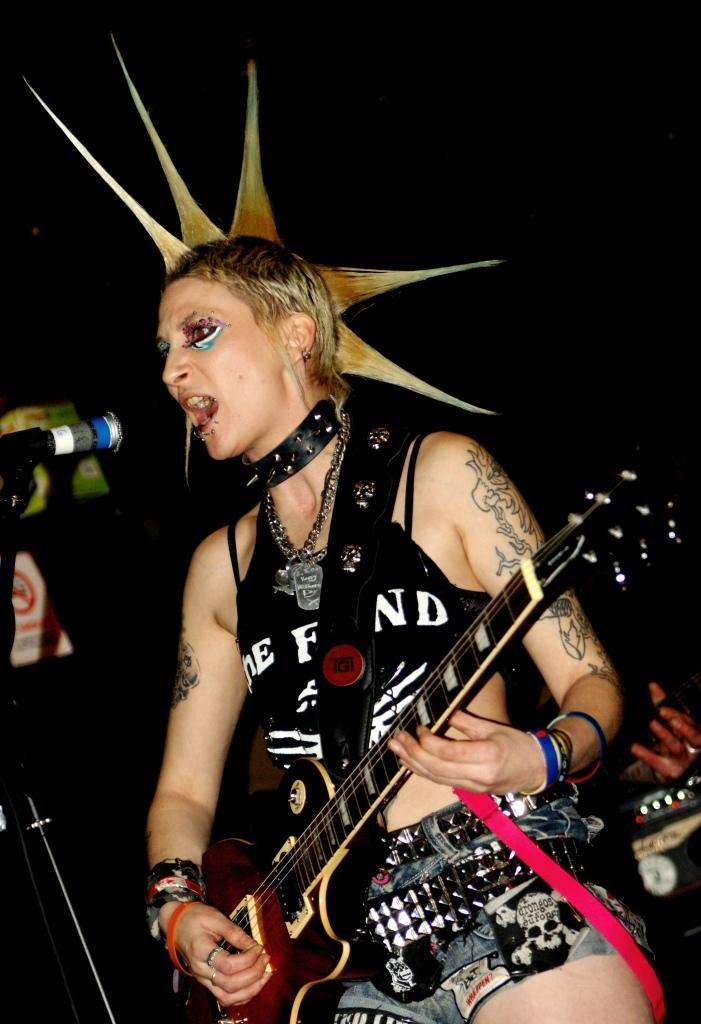Could you give a brief overview of what you see in this image? In this image there is a woman standing and playing a guitar and singing a song in the microphone , and at the back ground there is another person at the right side corner and name board attached to wall and there is a dark background. 